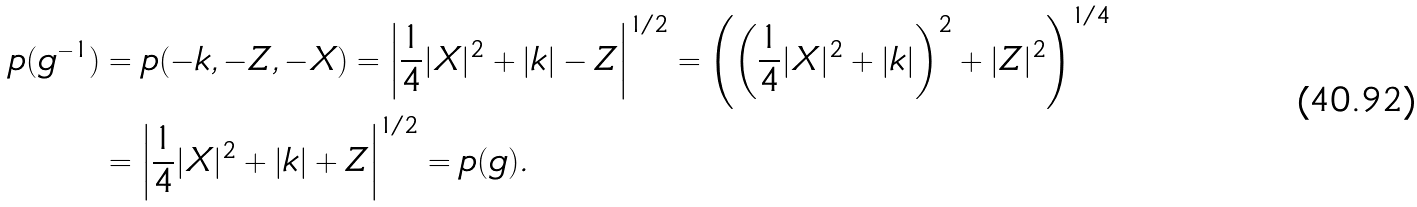<formula> <loc_0><loc_0><loc_500><loc_500>p ( g ^ { - 1 } ) & = p ( - k , - Z , - X ) = \left | \frac { 1 } { 4 } | X | ^ { 2 } + | k | - Z \right | ^ { 1 / 2 } = \left ( \left ( \frac { 1 } { 4 } | X | ^ { 2 } + | k | \right ) ^ { 2 } + | Z | ^ { 2 } \right ) ^ { 1 / 4 } \\ & = \left | \frac { 1 } { 4 } | X | ^ { 2 } + | k | + Z \right | ^ { 1 / 2 } = p ( g ) .</formula> 